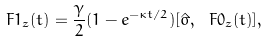Convert formula to latex. <formula><loc_0><loc_0><loc_500><loc_500>\ F { 1 } _ { z } ( t ) = \frac { \gamma } { 2 } ( 1 - e ^ { - \kappa t / 2 } ) [ \hat { \sigma } , \ F { 0 } _ { z } ( t ) ] ,</formula> 